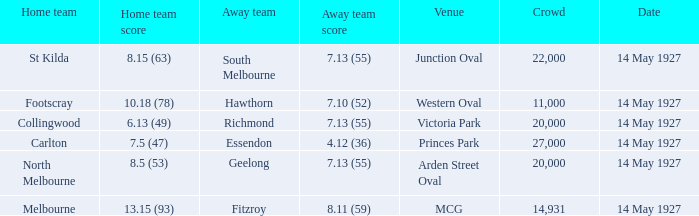How much is the sum of every crowd in attendance when the away score was 7.13 (55) for Richmond? 20000.0. 